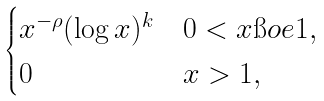<formula> <loc_0><loc_0><loc_500><loc_500>\begin{cases} x ^ { - \rho } ( \log x ) ^ { k } & 0 < x \i o e 1 , \\ 0 & x > 1 , \end{cases}</formula> 